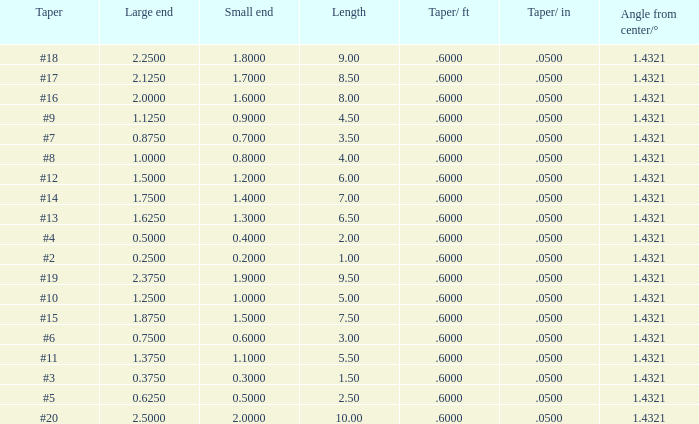Which Length has a Taper of #15, and a Large end larger than 1.875? None. 